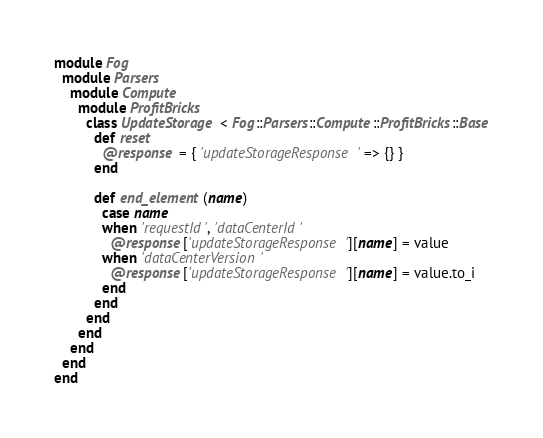Convert code to text. <code><loc_0><loc_0><loc_500><loc_500><_Ruby_>module Fog
  module Parsers
    module Compute
      module ProfitBricks
        class UpdateStorage < Fog::Parsers::Compute::ProfitBricks::Base
          def reset
            @response = { 'updateStorageResponse' => {} }
          end

          def end_element(name)
            case name
            when 'requestId', 'dataCenterId'
              @response['updateStorageResponse'][name] = value
            when 'dataCenterVersion'
              @response['updateStorageResponse'][name] = value.to_i
            end
          end
        end
      end
    end
  end
end
</code> 